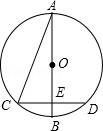What geometric principles can be directly observed in this circle diagram? This diagram showcases several fundamental principles of geometry, including the properties of perpendicular bisectors, as CD bisects AB at right angles implying E is equidistant from C and D. Furthermore, it illustrates the properties of the isosceles triangle in AOC and an isosceles right triangle in OCE, which help deduce the relations between angles and sides critical in solving for the circle's radius. 